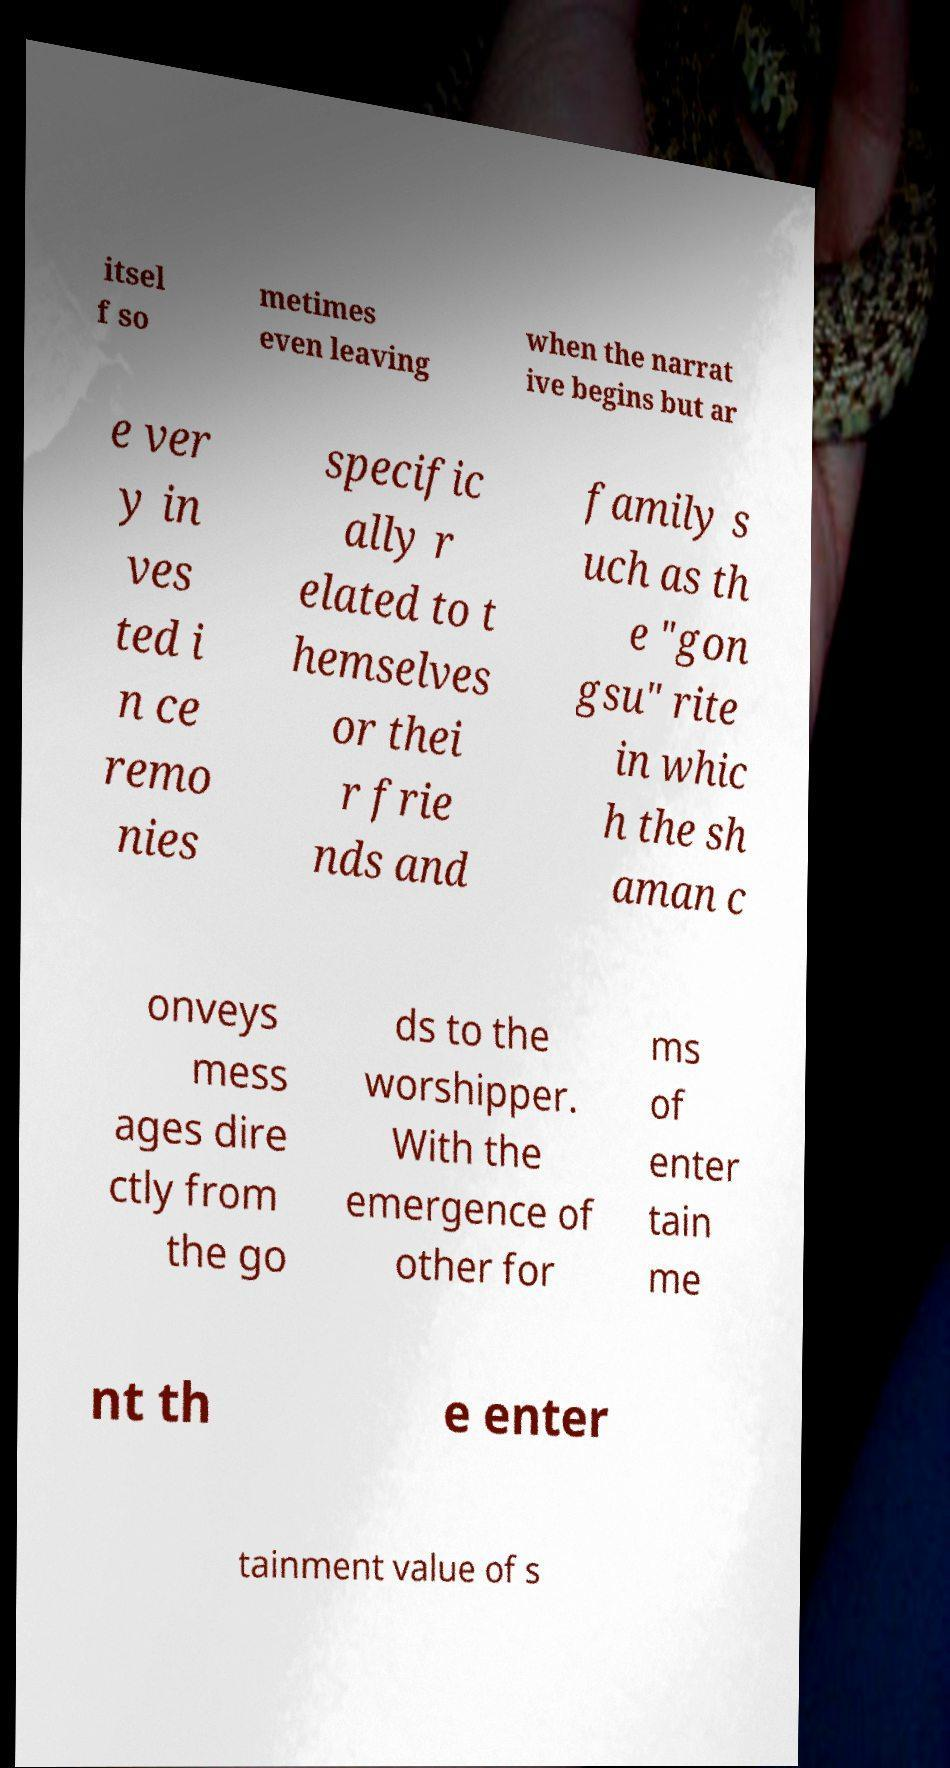There's text embedded in this image that I need extracted. Can you transcribe it verbatim? itsel f so metimes even leaving when the narrat ive begins but ar e ver y in ves ted i n ce remo nies specific ally r elated to t hemselves or thei r frie nds and family s uch as th e "gon gsu" rite in whic h the sh aman c onveys mess ages dire ctly from the go ds to the worshipper. With the emergence of other for ms of enter tain me nt th e enter tainment value of s 